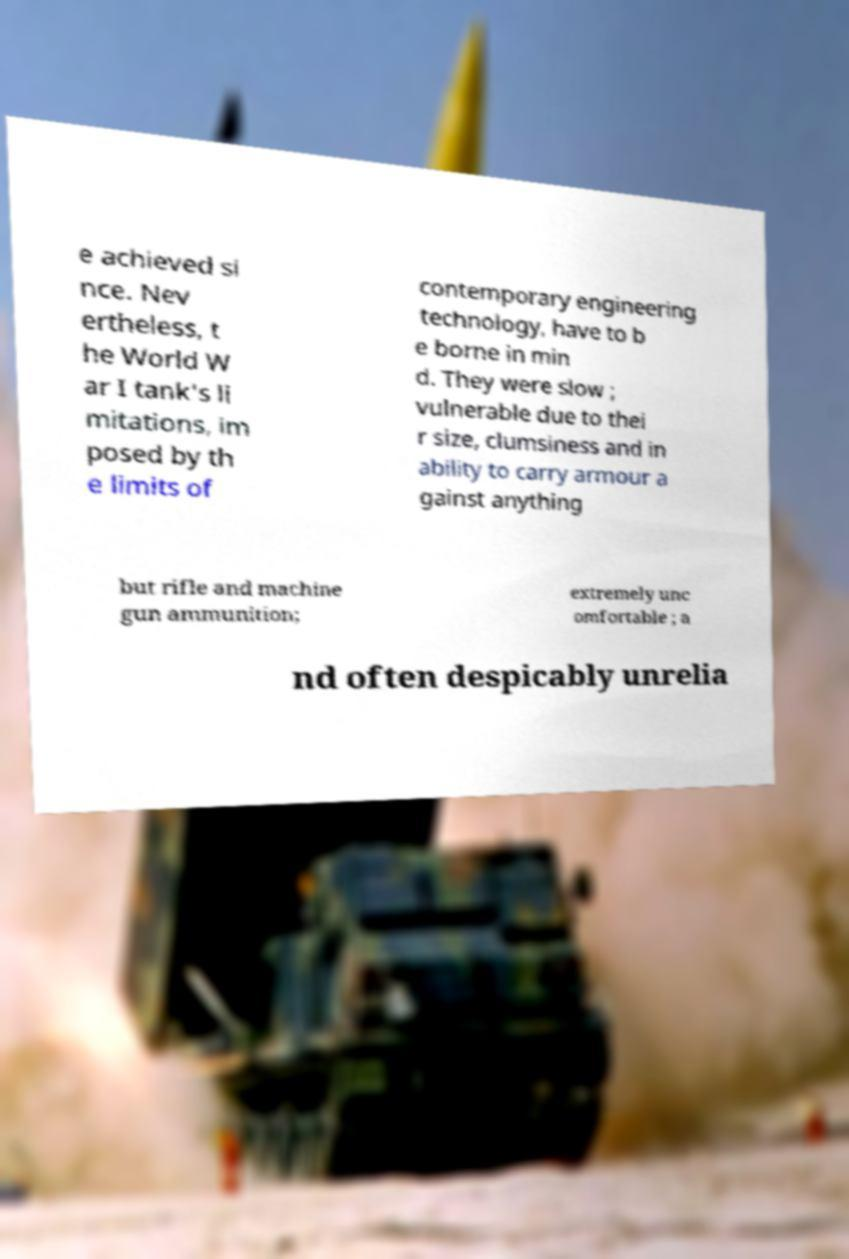For documentation purposes, I need the text within this image transcribed. Could you provide that? e achieved si nce. Nev ertheless, t he World W ar I tank's li mitations, im posed by th e limits of contemporary engineering technology, have to b e borne in min d. They were slow ; vulnerable due to thei r size, clumsiness and in ability to carry armour a gainst anything but rifle and machine gun ammunition; extremely unc omfortable ; a nd often despicably unrelia 